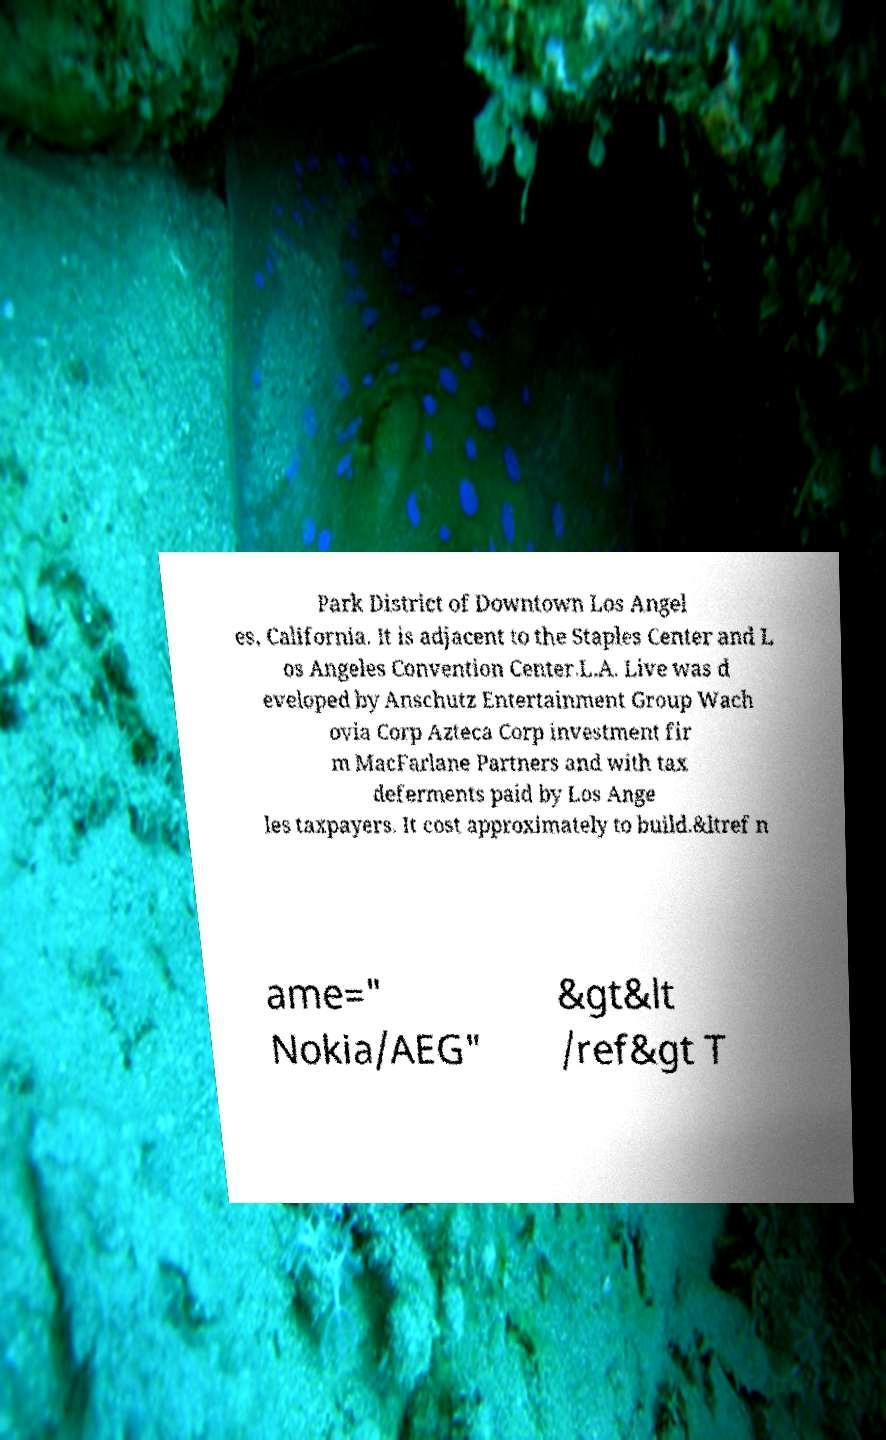Could you extract and type out the text from this image? Park District of Downtown Los Angel es, California. It is adjacent to the Staples Center and L os Angeles Convention Center.L.A. Live was d eveloped by Anschutz Entertainment Group Wach ovia Corp Azteca Corp investment fir m MacFarlane Partners and with tax deferments paid by Los Ange les taxpayers. It cost approximately to build.&ltref n ame=" Nokia/AEG" &gt&lt /ref&gt T 